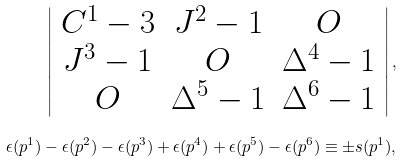Convert formula to latex. <formula><loc_0><loc_0><loc_500><loc_500>\left | \begin{array} { c c c } C ^ { 1 } - 3 & J ^ { 2 } - 1 & O \\ J ^ { 3 } - 1 & O & \Delta ^ { 4 } - 1 \\ O & \Delta ^ { 5 } - 1 & \Delta ^ { 6 } - 1 \\ \end{array} \right | , \\ \epsilon ( p ^ { 1 } ) - \epsilon ( p ^ { 2 } ) - \epsilon ( p ^ { 3 } ) + \epsilon ( p ^ { 4 } ) + \epsilon ( p ^ { 5 } ) - \epsilon ( p ^ { 6 } ) \equiv \pm s ( p ^ { 1 } ) ,</formula> 